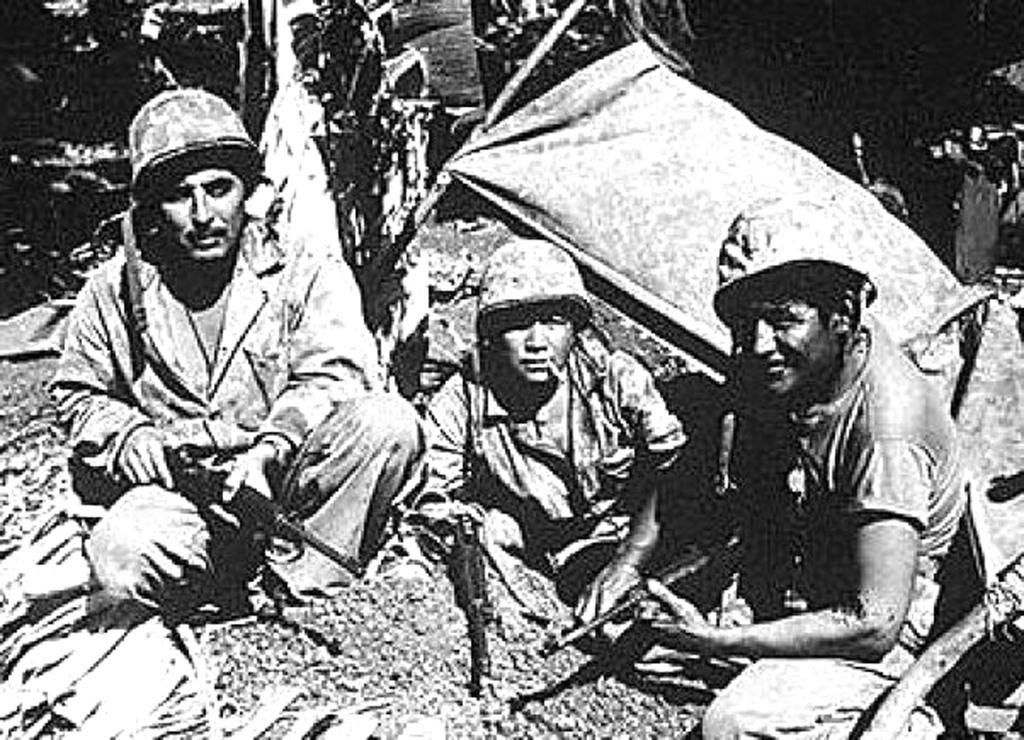What is the color scheme of the image? The image is black and white. How many people are in the image? There are three persons in the image. What can be inferred about the occupation of the persons in the image? The persons appear to be military personnel. What are the military personnel holding in the image? The military personnel are holding guns. What protective gear are the military personnel wearing in the image? The military personnel are wearing helmets. What type of grain is being harvested in the image? There is no grain or harvesting activity present in the image. What scientific experiment is being conducted in the image? There is no scientific experiment or laboratory setting present in the image. 